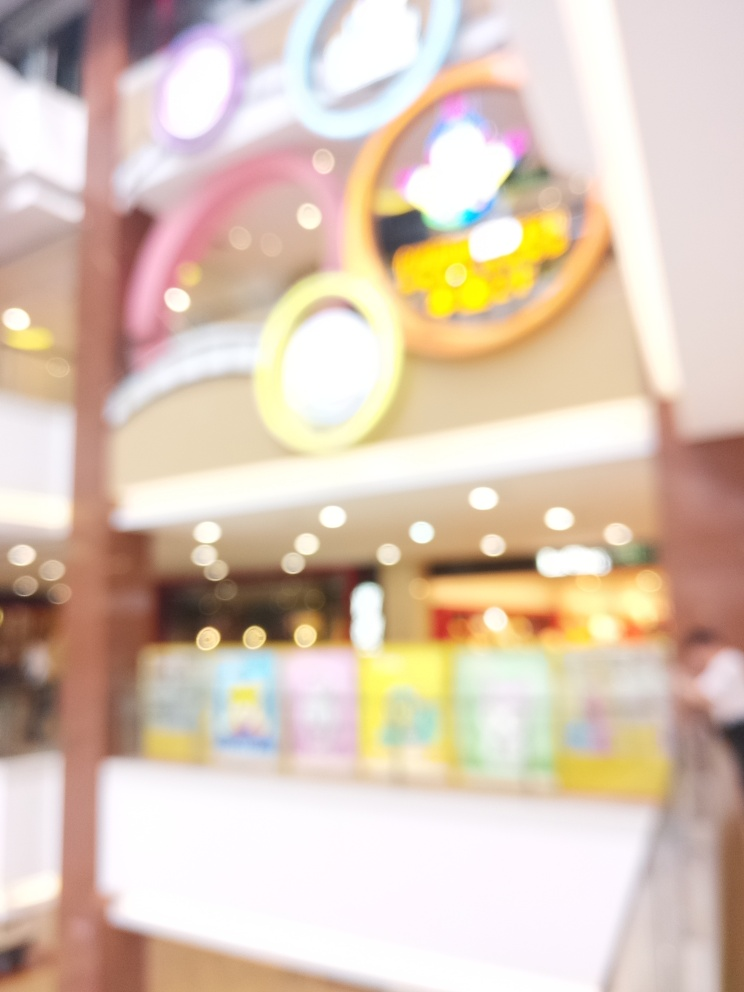Has the main subject lost most of its detailed textures?
A. Yes
B. No
Answer with the option's letter from the given choices directly.
 A. 